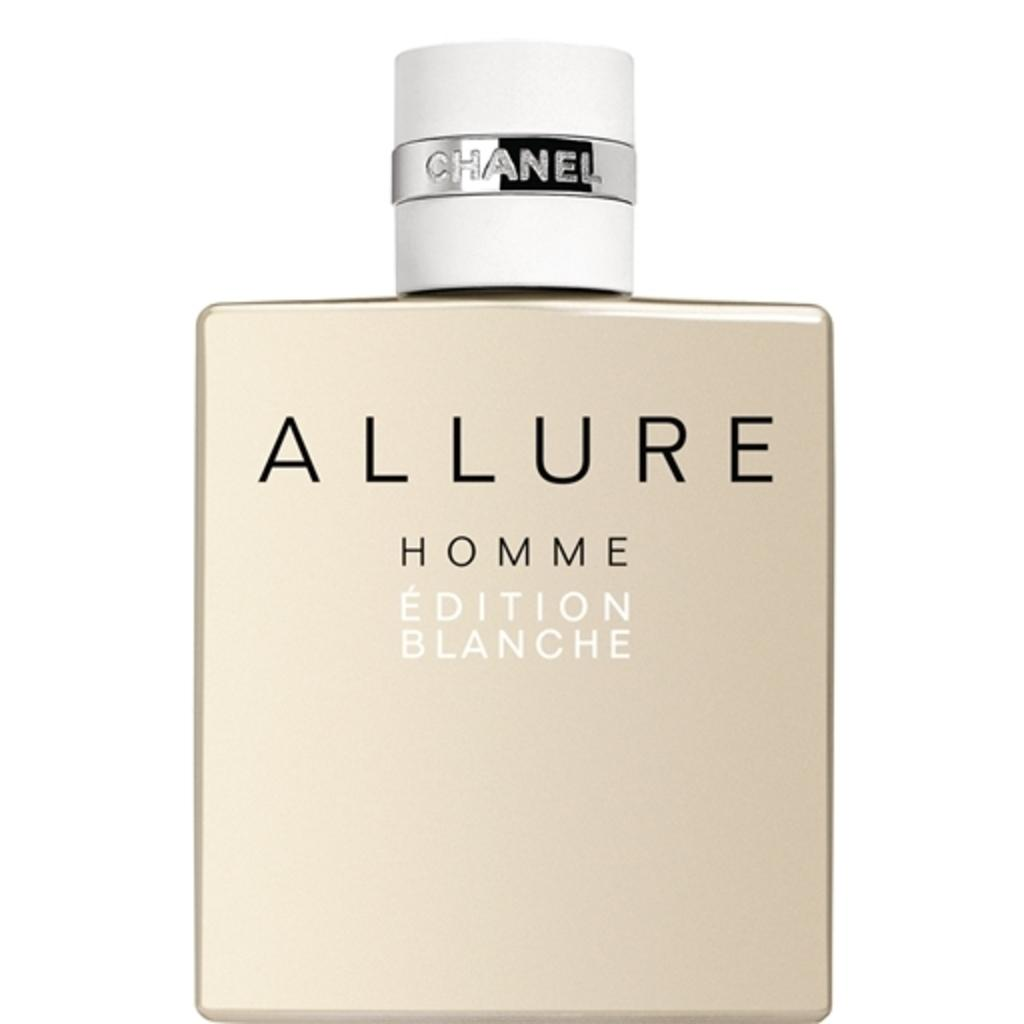<image>
Give a short and clear explanation of the subsequent image. Bottle of perfume named Allure in front of a white background. 